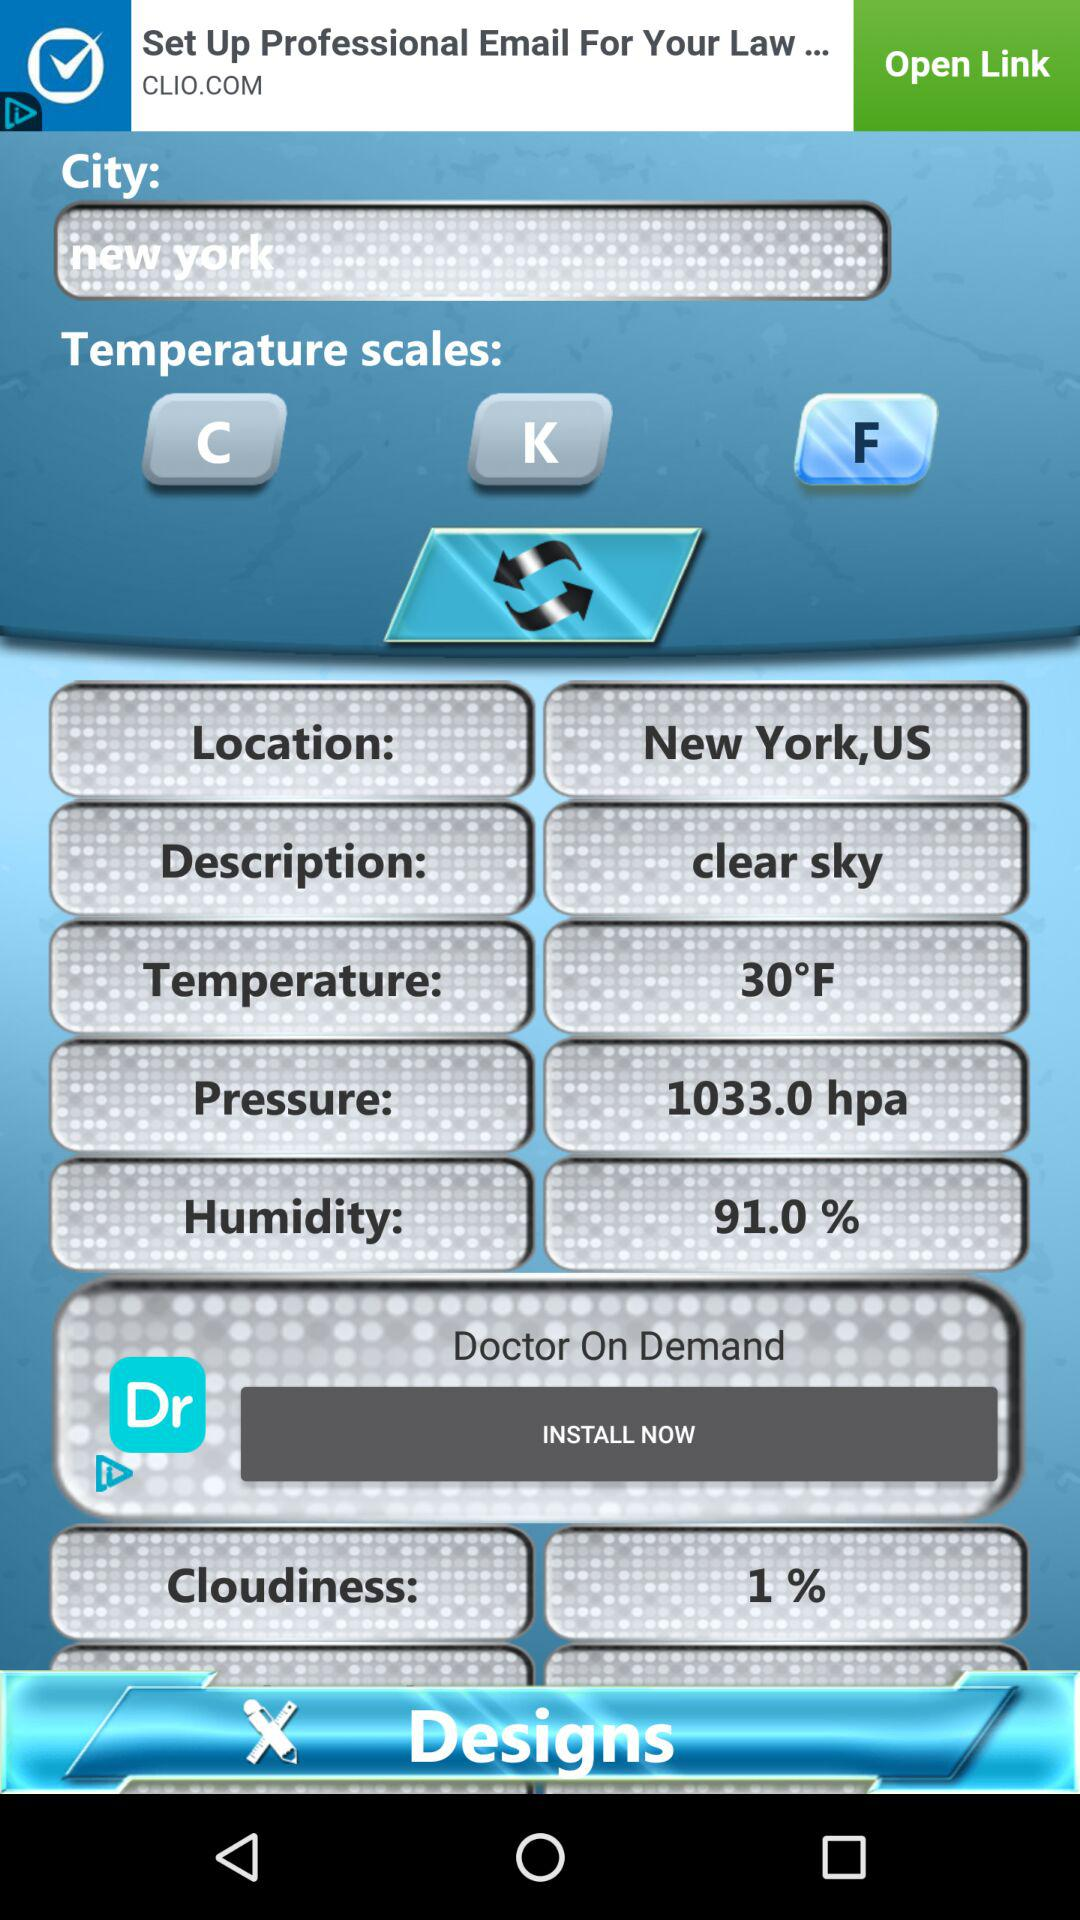Which temperature scale button has been selected? The selected temperature scale button is "F". 